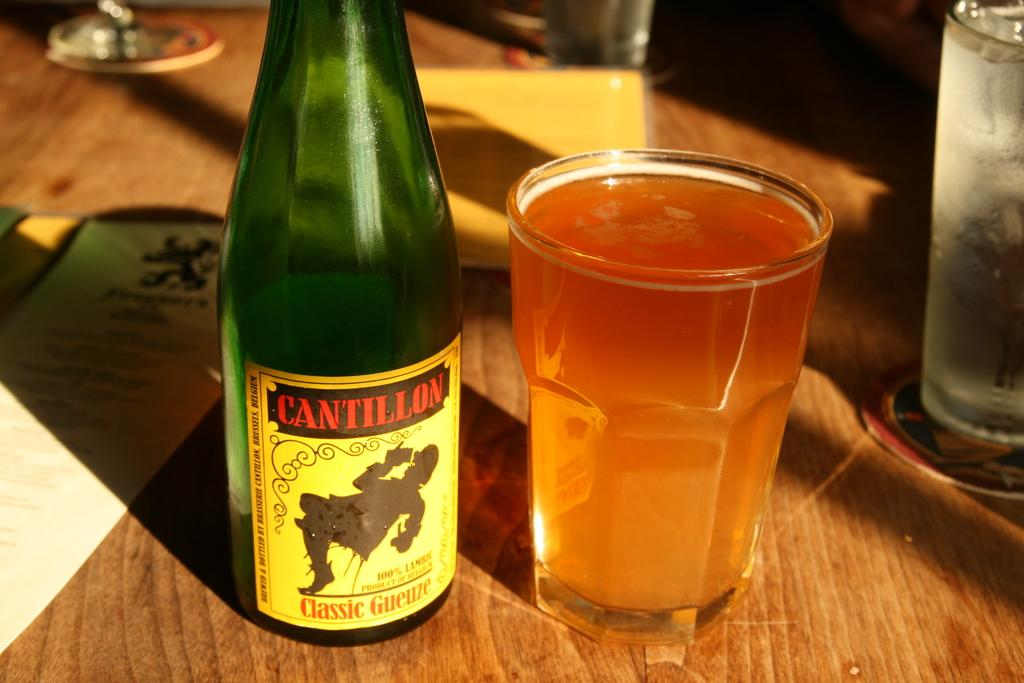<image>
Offer a succinct explanation of the picture presented. A bottle of Cantillon sits on a table poured into a glass 